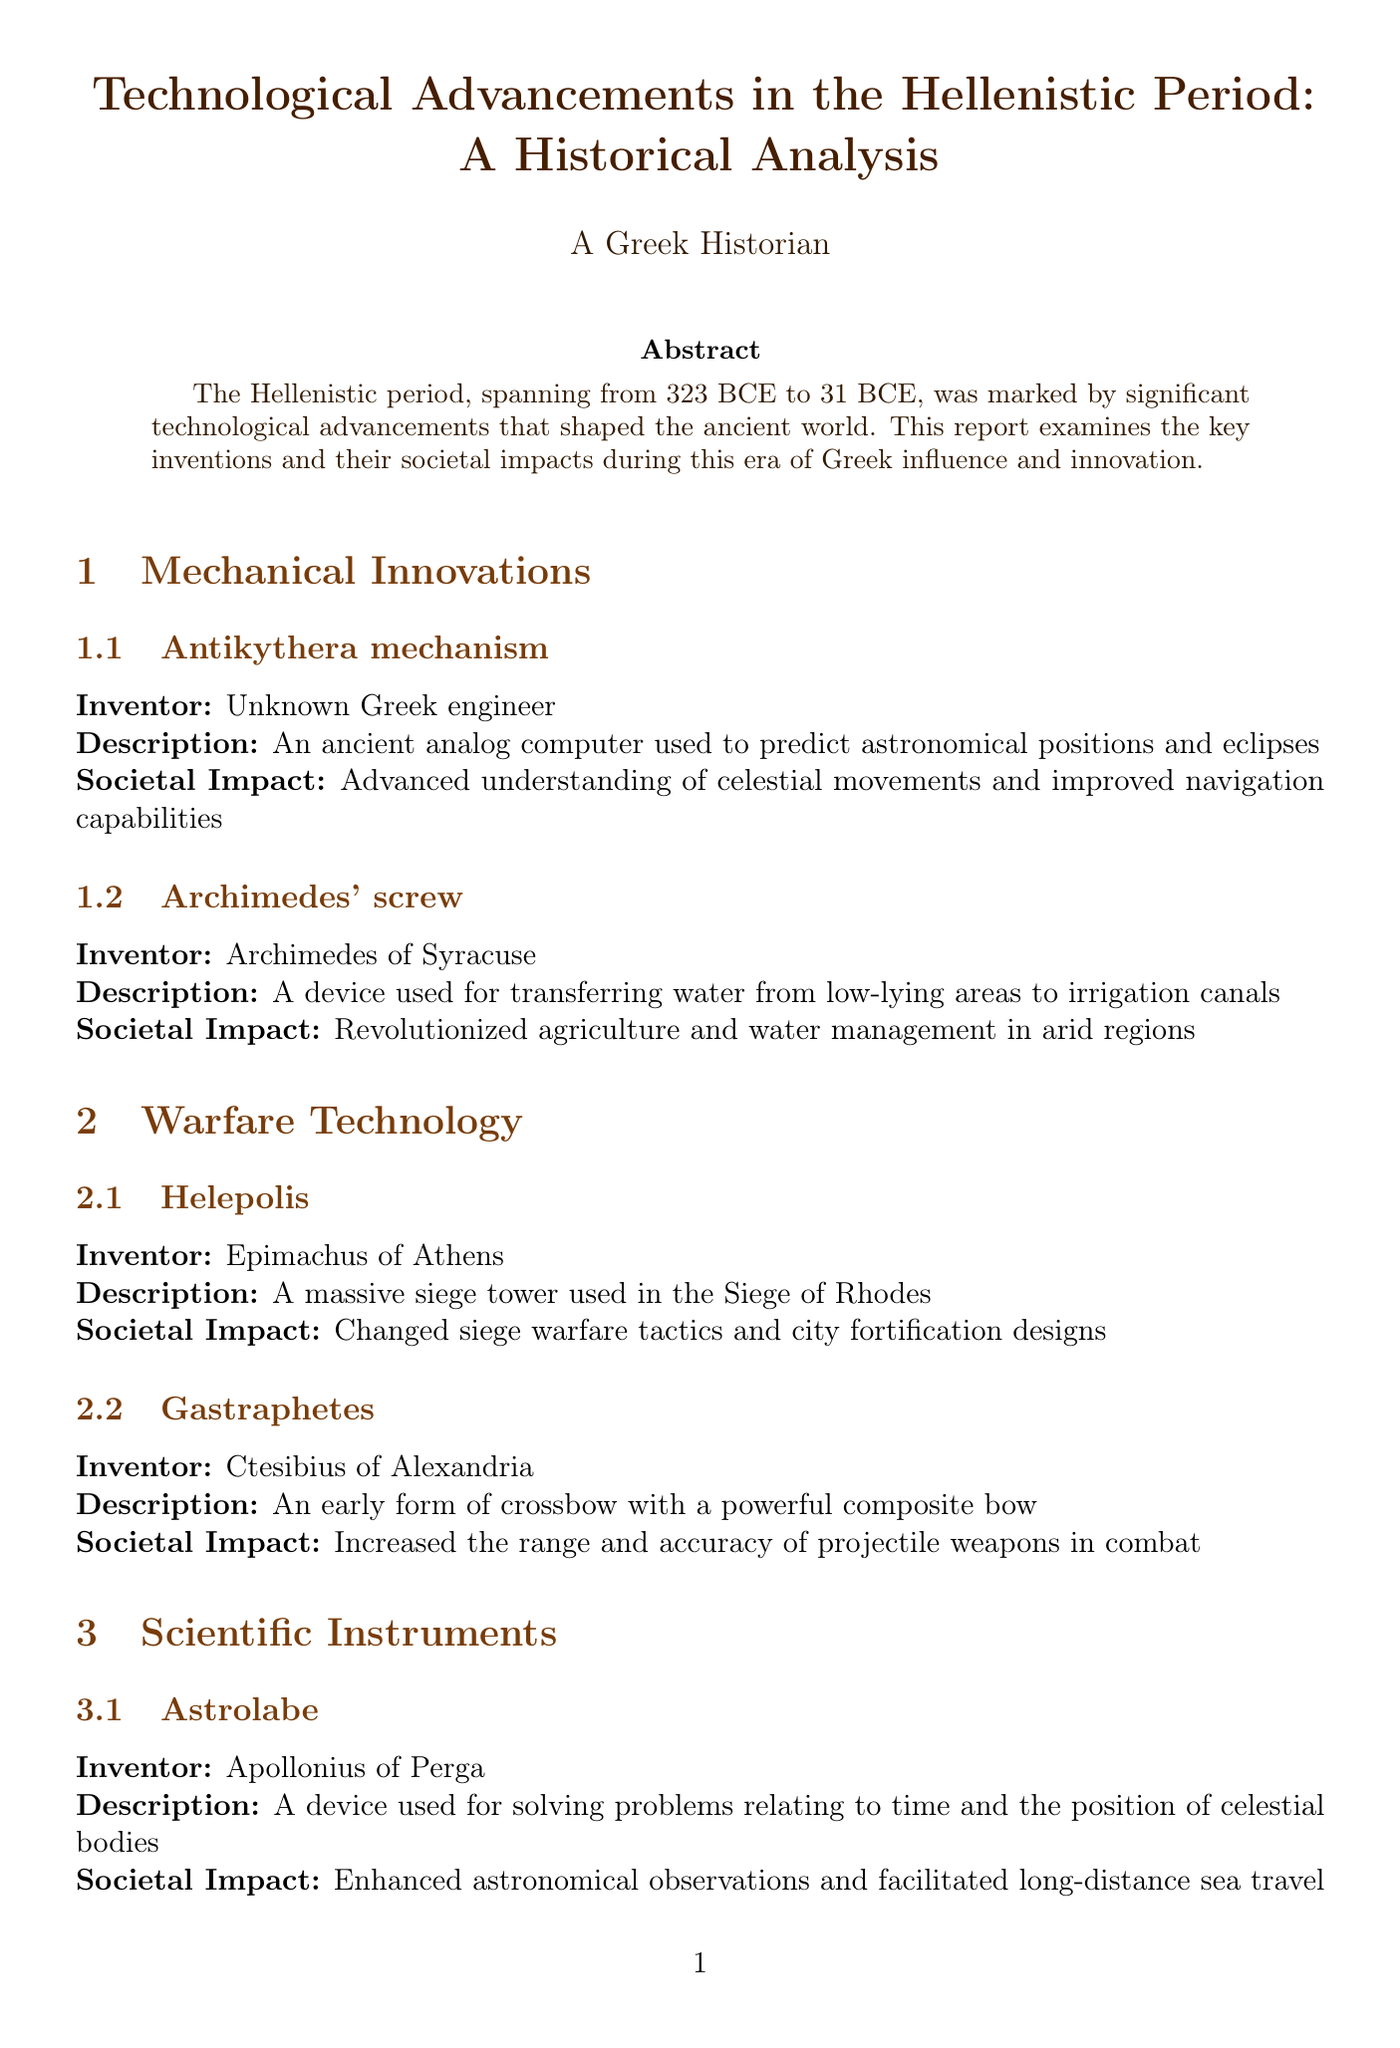What is the time span of the Hellenistic period? The Hellenistic period is described to have occurred from 323 BCE to 31 BCE.
Answer: 323 BCE to 31 BCE Who invented the Antikythera mechanism? The document states that the inventor of the Antikythera mechanism is an unknown Greek engineer.
Answer: Unknown Greek engineer What was the societal impact of Archimedes' screw? The report indicates that it revolutionized agriculture and water management in arid regions.
Answer: Revolutionized agriculture and water management What is one of the Seven Wonders of the Ancient World mentioned in the report? The Lighthouse of Alexandria is explicitly referred to as one of the Seven Wonders in the document.
Answer: Lighthouse of Alexandria Which invention is attributed to Ctesibius of Alexandria? The Gastraphetes is identified as the invention attributed to Ctesibius of Alexandria in the report.
Answer: Gastraphetes What historical figure is associated with the development of the Astrolabe? The document mentions Apollonius of Perga as the inventor of the Astrolabe.
Answer: Apollonius of Perga What is noted as having improved maritime safety? The document highlights the Lighthouse of Alexandria as significantly improving maritime safety.
Answer: Lighthouse of Alexandria What societal impact did the Helepolis have on warfare? The societal impact described in the report states it changed siege warfare tactics and city fortification designs.
Answer: Changed siege warfare tactics and city fortification designs 